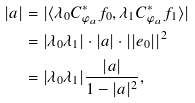Convert formula to latex. <formula><loc_0><loc_0><loc_500><loc_500>| a | & = | \langle \lambda _ { 0 } C _ { \varphi _ { a } } ^ { * } f _ { 0 } , \lambda _ { 1 } C _ { \varphi _ { a } } ^ { * } f _ { 1 } \rangle | \\ & = | \lambda _ { 0 } \lambda _ { 1 } | \cdot | a | \cdot | | e _ { 0 } | | ^ { 2 } \\ & = | \lambda _ { 0 } \lambda _ { 1 } | \frac { | a | } { 1 - | a | ^ { 2 } } ,</formula> 